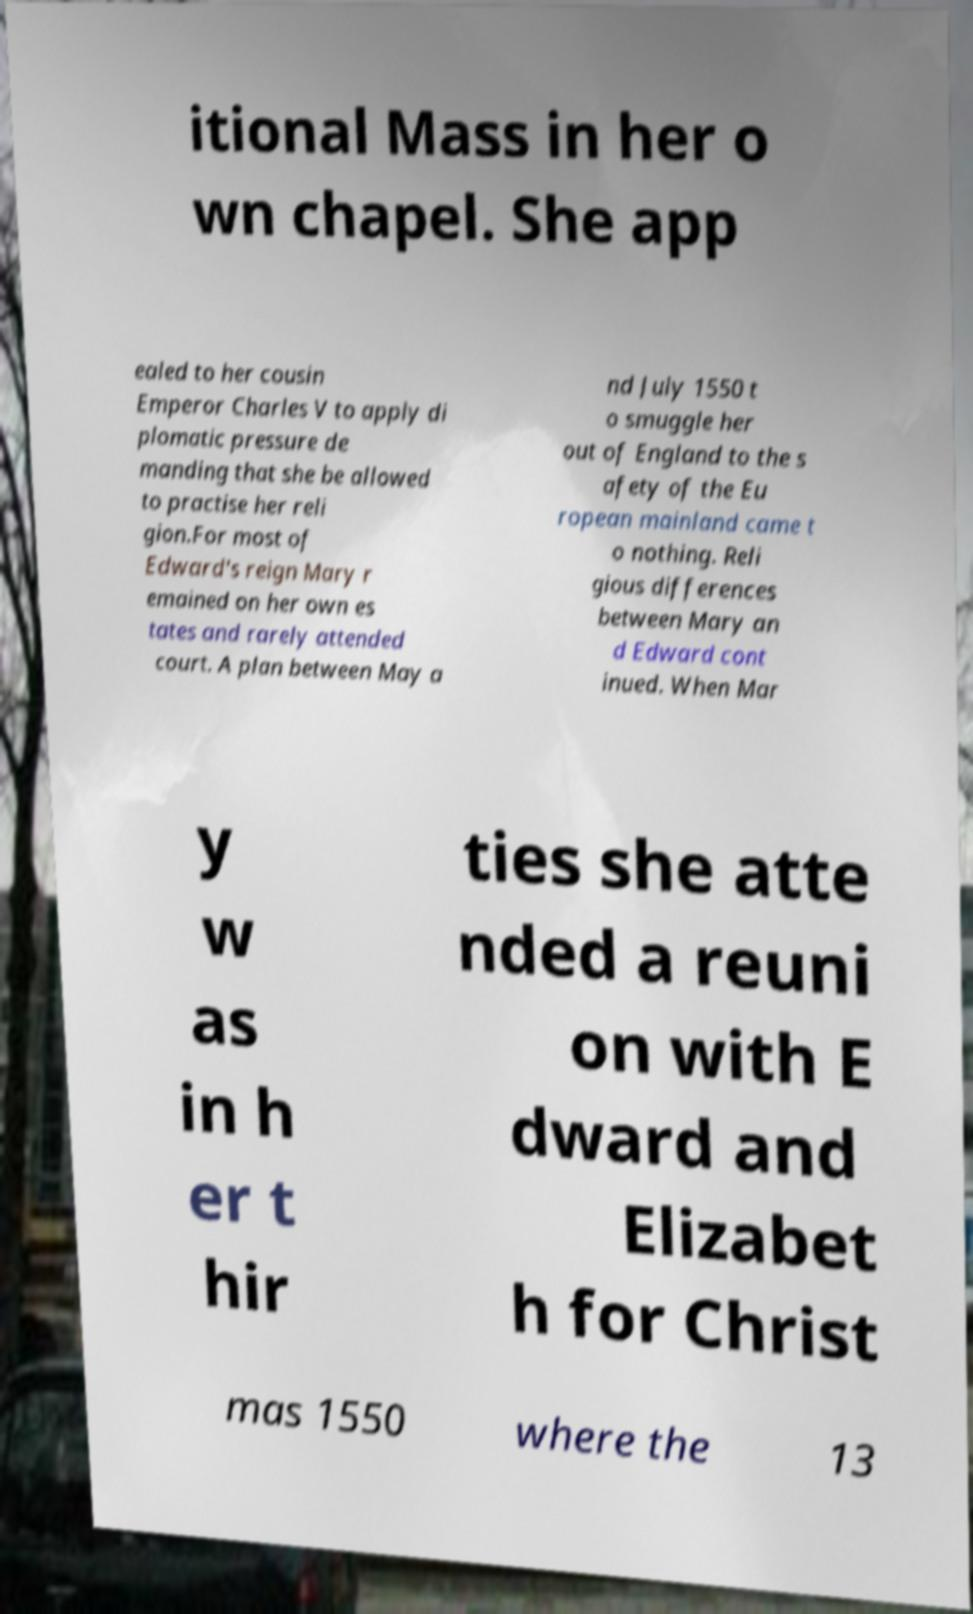I need the written content from this picture converted into text. Can you do that? itional Mass in her o wn chapel. She app ealed to her cousin Emperor Charles V to apply di plomatic pressure de manding that she be allowed to practise her reli gion.For most of Edward's reign Mary r emained on her own es tates and rarely attended court. A plan between May a nd July 1550 t o smuggle her out of England to the s afety of the Eu ropean mainland came t o nothing. Reli gious differences between Mary an d Edward cont inued. When Mar y w as in h er t hir ties she atte nded a reuni on with E dward and Elizabet h for Christ mas 1550 where the 13 